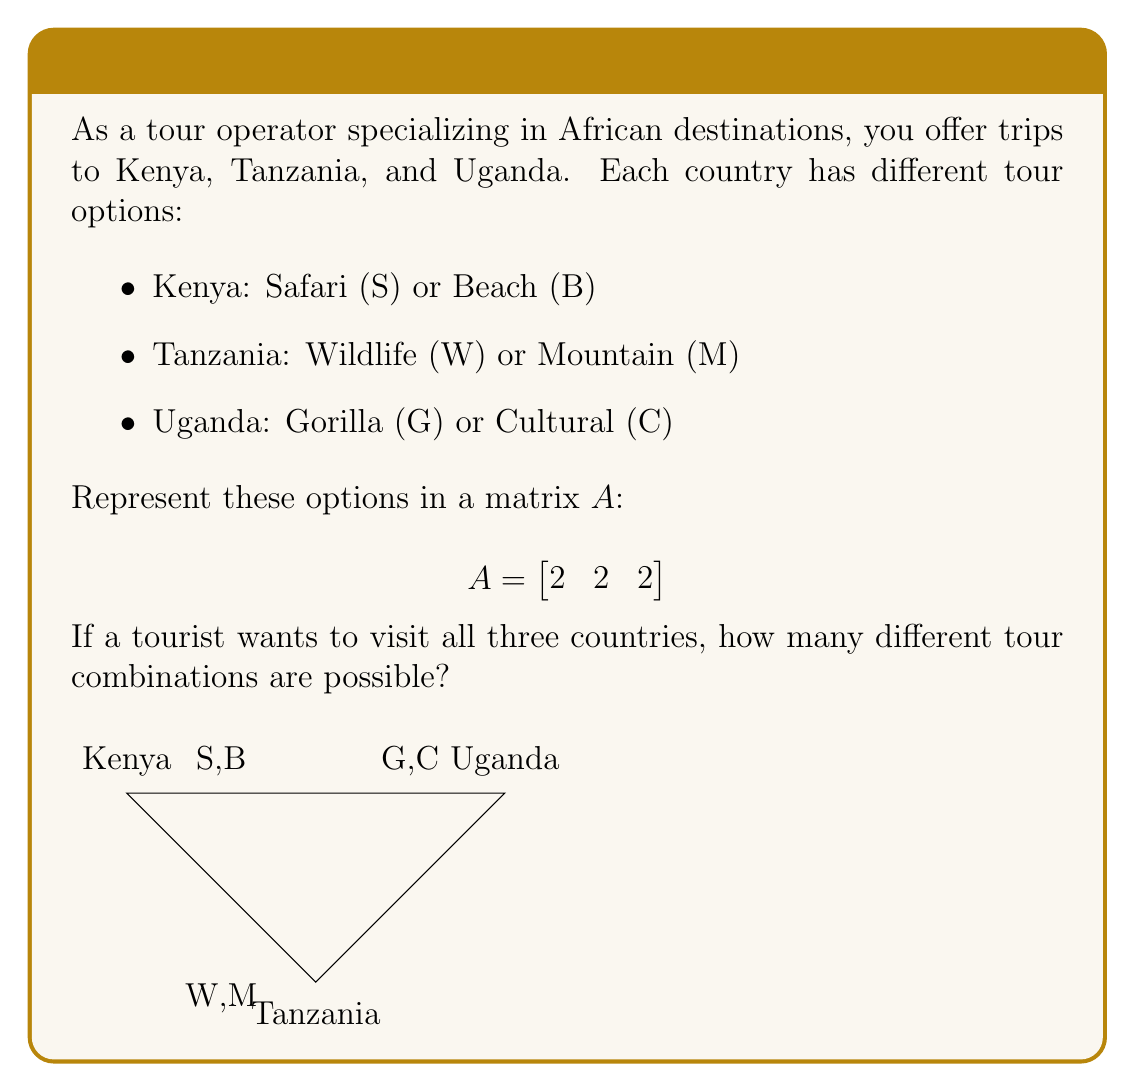Could you help me with this problem? Let's approach this step-by-step:

1) The matrix $A$ represents the number of options for each country:
   $$A = \begin{bmatrix}
   2 & 2 & 2
   \end{bmatrix}$$

2) To find the total number of combinations, we need to multiply these options:
   $2 \times 2 \times 2$

3) In matrix notation, this is equivalent to multiplying the elements:
   $$A \times A^T = \begin{bmatrix}
   2 & 2 & 2
   \end{bmatrix} \times \begin{bmatrix}
   2 \\ 2 \\ 2
   \end{bmatrix}$$

4) Performing the matrix multiplication:
   $$(2 \times 2) + (2 \times 2) + (2 \times 2) = 4 + 4 + 4 = 12$$

5) However, this result (12) doesn't represent the actual number of combinations. It's the sum of the possible combinations for each pair of countries.

6) The correct number of combinations is actually the product of the options:
   $$2 \times 2 \times 2 = 8$$

This can be verified by listing all possible combinations:
(S,W,G), (S,W,C), (S,M,G), (S,M,C), (B,W,G), (B,W,C), (B,M,G), (B,M,C)
Answer: 8 combinations 